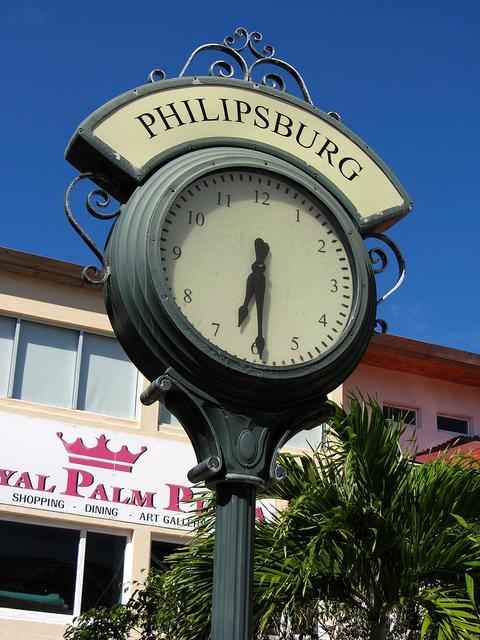What time is the clock showing?
Concise answer only. 6:30. Is this a typical clock you would see in an American park?
Quick response, please. Yes. What does it say on top of the clock?
Give a very brief answer. Philipsburg. What is the 4-letter word under the pink crown on the sign?
Concise answer only. Palm. 